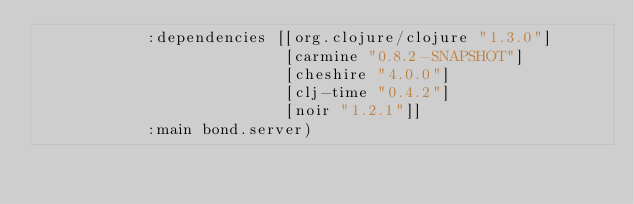Convert code to text. <code><loc_0><loc_0><loc_500><loc_500><_Clojure_>            :dependencies [[org.clojure/clojure "1.3.0"]
                           [carmine "0.8.2-SNAPSHOT"]
                           [cheshire "4.0.0"]
                           [clj-time "0.4.2"]
                           [noir "1.2.1"]]
            :main bond.server)

</code> 